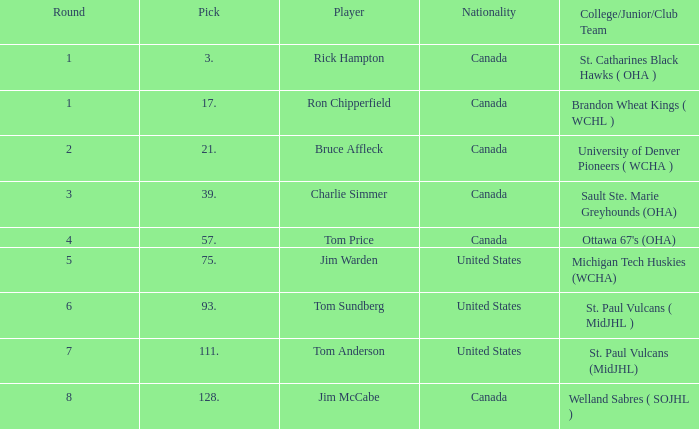Can you tell me the College/Junior/Club Team that has the Round of 4? Ottawa 67's (OHA). 